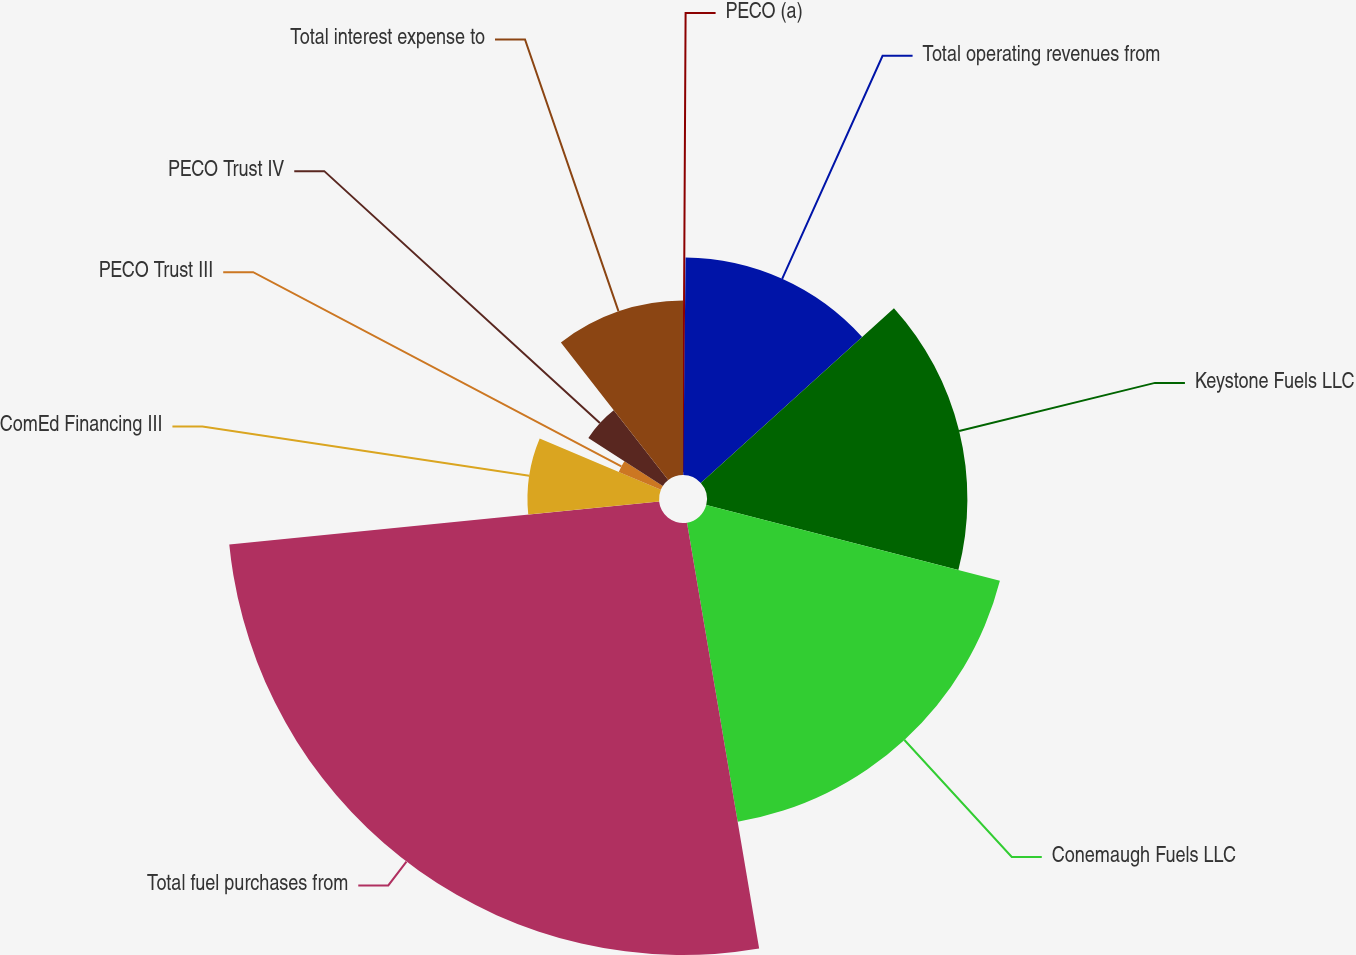Convert chart to OTSL. <chart><loc_0><loc_0><loc_500><loc_500><pie_chart><fcel>PECO (a)<fcel>Total operating revenues from<fcel>Keystone Fuels LLC<fcel>Conemaugh Fuels LLC<fcel>Total fuel purchases from<fcel>ComEd Financing III<fcel>PECO Trust III<fcel>PECO Trust IV<fcel>Total interest expense to<nl><fcel>0.17%<fcel>13.13%<fcel>15.72%<fcel>18.31%<fcel>26.08%<fcel>7.94%<fcel>2.76%<fcel>5.35%<fcel>10.54%<nl></chart> 